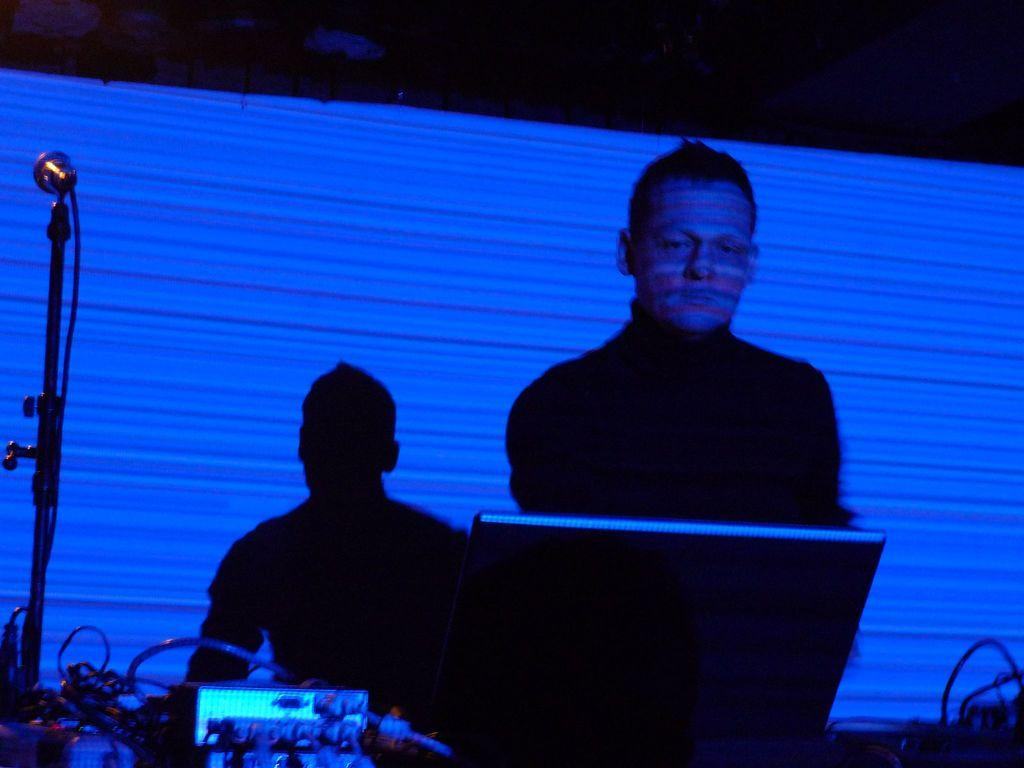Who is present in the image? There is a man in the image. What object is the man holding in the image? The man is holding a microphone (mike) in the image. What else can be seen in the image besides the man and the microphone? There are cables and devices visible in the image. Can you describe the shadow in the background of the image? There is a shadow of a person on a banner in the background of the image. What type of current can be seen flowing through the boats in the image? There are no boats present in the image, so there is no current to be observed. 